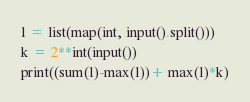<code> <loc_0><loc_0><loc_500><loc_500><_Python_>l = list(map(int, input().split()))
k = 2**int(input())
print((sum(l)-max(l))+ max(l)*k)</code> 